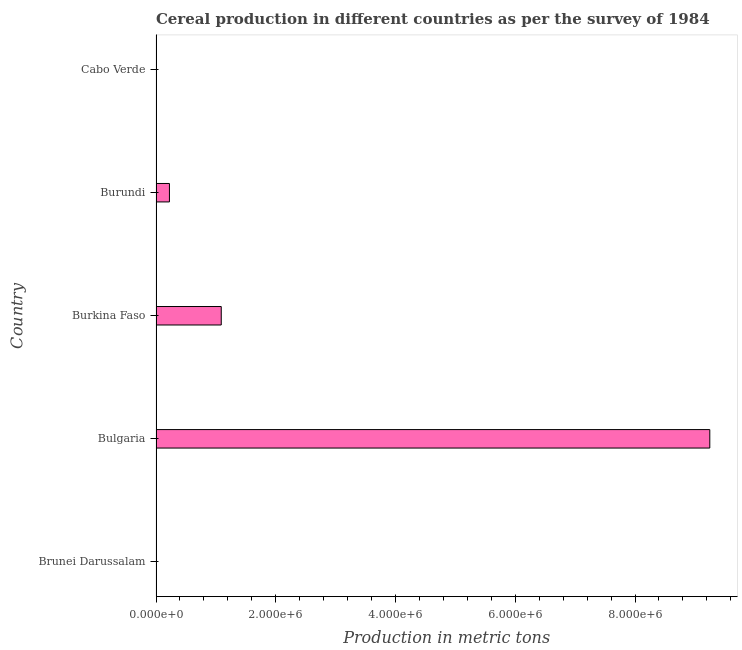Does the graph contain any zero values?
Your response must be concise. No. What is the title of the graph?
Your response must be concise. Cereal production in different countries as per the survey of 1984. What is the label or title of the X-axis?
Ensure brevity in your answer.  Production in metric tons. What is the label or title of the Y-axis?
Your answer should be compact. Country. What is the cereal production in Brunei Darussalam?
Give a very brief answer. 3270. Across all countries, what is the maximum cereal production?
Ensure brevity in your answer.  9.25e+06. Across all countries, what is the minimum cereal production?
Give a very brief answer. 2525. In which country was the cereal production minimum?
Provide a short and direct response. Cabo Verde. What is the sum of the cereal production?
Make the answer very short. 1.06e+07. What is the difference between the cereal production in Burkina Faso and Burundi?
Provide a succinct answer. 8.65e+05. What is the average cereal production per country?
Offer a very short reply. 2.11e+06. What is the median cereal production?
Provide a short and direct response. 2.24e+05. In how many countries, is the cereal production greater than 5600000 metric tons?
Your answer should be very brief. 1. What is the ratio of the cereal production in Burkina Faso to that in Cabo Verde?
Give a very brief answer. 431.43. Is the cereal production in Bulgaria less than that in Burkina Faso?
Provide a succinct answer. No. What is the difference between the highest and the second highest cereal production?
Provide a short and direct response. 8.16e+06. What is the difference between the highest and the lowest cereal production?
Your answer should be very brief. 9.25e+06. How many bars are there?
Provide a succinct answer. 5. Are all the bars in the graph horizontal?
Provide a short and direct response. Yes. How many countries are there in the graph?
Offer a very short reply. 5. Are the values on the major ticks of X-axis written in scientific E-notation?
Offer a terse response. Yes. What is the Production in metric tons of Brunei Darussalam?
Keep it short and to the point. 3270. What is the Production in metric tons in Bulgaria?
Give a very brief answer. 9.25e+06. What is the Production in metric tons in Burkina Faso?
Provide a short and direct response. 1.09e+06. What is the Production in metric tons of Burundi?
Provide a succinct answer. 2.24e+05. What is the Production in metric tons in Cabo Verde?
Ensure brevity in your answer.  2525. What is the difference between the Production in metric tons in Brunei Darussalam and Bulgaria?
Provide a succinct answer. -9.25e+06. What is the difference between the Production in metric tons in Brunei Darussalam and Burkina Faso?
Make the answer very short. -1.09e+06. What is the difference between the Production in metric tons in Brunei Darussalam and Burundi?
Offer a terse response. -2.21e+05. What is the difference between the Production in metric tons in Brunei Darussalam and Cabo Verde?
Your response must be concise. 745. What is the difference between the Production in metric tons in Bulgaria and Burkina Faso?
Provide a succinct answer. 8.16e+06. What is the difference between the Production in metric tons in Bulgaria and Burundi?
Your answer should be very brief. 9.03e+06. What is the difference between the Production in metric tons in Bulgaria and Cabo Verde?
Ensure brevity in your answer.  9.25e+06. What is the difference between the Production in metric tons in Burkina Faso and Burundi?
Ensure brevity in your answer.  8.65e+05. What is the difference between the Production in metric tons in Burkina Faso and Cabo Verde?
Your answer should be compact. 1.09e+06. What is the difference between the Production in metric tons in Burundi and Cabo Verde?
Provide a short and direct response. 2.21e+05. What is the ratio of the Production in metric tons in Brunei Darussalam to that in Bulgaria?
Offer a very short reply. 0. What is the ratio of the Production in metric tons in Brunei Darussalam to that in Burkina Faso?
Provide a succinct answer. 0. What is the ratio of the Production in metric tons in Brunei Darussalam to that in Burundi?
Make the answer very short. 0.01. What is the ratio of the Production in metric tons in Brunei Darussalam to that in Cabo Verde?
Your response must be concise. 1.29. What is the ratio of the Production in metric tons in Bulgaria to that in Burkina Faso?
Your answer should be very brief. 8.49. What is the ratio of the Production in metric tons in Bulgaria to that in Burundi?
Your response must be concise. 41.29. What is the ratio of the Production in metric tons in Bulgaria to that in Cabo Verde?
Provide a short and direct response. 3663.03. What is the ratio of the Production in metric tons in Burkina Faso to that in Burundi?
Ensure brevity in your answer.  4.86. What is the ratio of the Production in metric tons in Burkina Faso to that in Cabo Verde?
Offer a terse response. 431.43. What is the ratio of the Production in metric tons in Burundi to that in Cabo Verde?
Your response must be concise. 88.71. 